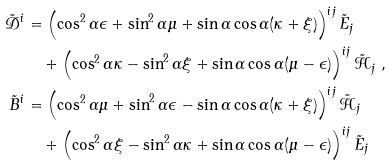Convert formula to latex. <formula><loc_0><loc_0><loc_500><loc_500>\tilde { \mathcal { D } } ^ { i } & = \left ( \cos ^ { 2 } \alpha \epsilon + \sin ^ { 2 } \alpha \mu + \sin \alpha \cos \alpha ( \kappa + \xi ) \right ) ^ { i j } \tilde { E } _ { j } \\ & \quad + \left ( \cos ^ { 2 } \alpha \kappa - \sin ^ { 2 } \alpha \xi + \sin \alpha \cos \alpha ( \mu - \epsilon ) \right ) ^ { i j } \tilde { \mathcal { H } } _ { j } \ , \\ \tilde { B } ^ { i } & = \left ( \cos ^ { 2 } \alpha \mu + \sin ^ { 2 } \alpha \epsilon - \sin \alpha \cos \alpha ( \kappa + \xi ) \right ) ^ { i j } \tilde { \mathcal { H } } _ { j } \\ & \quad + \left ( \cos ^ { 2 } \alpha \xi - \sin ^ { 2 } \alpha \kappa + \sin \alpha \cos \alpha ( \mu - \epsilon ) \right ) ^ { i j } \tilde { E } _ { j }</formula> 